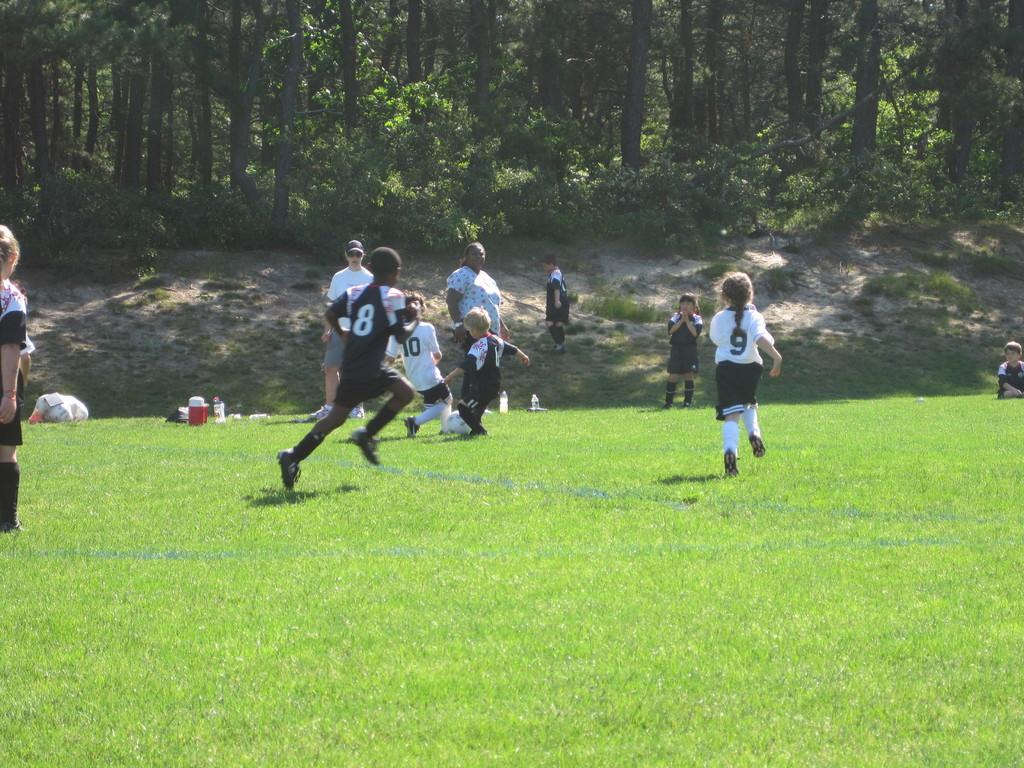What can be seen in the background of the image? There are trees in the background of the image. What is the color of the grass in the image? The area has green grass. What are the people in the image doing? There are people playing and running in the image. Can you tell me the position of the squirrel in the image? There is no squirrel present in the image. How do the people stop running in the image? The provided facts do not mention any stopping or pausing in the actions of the people running in the image. 